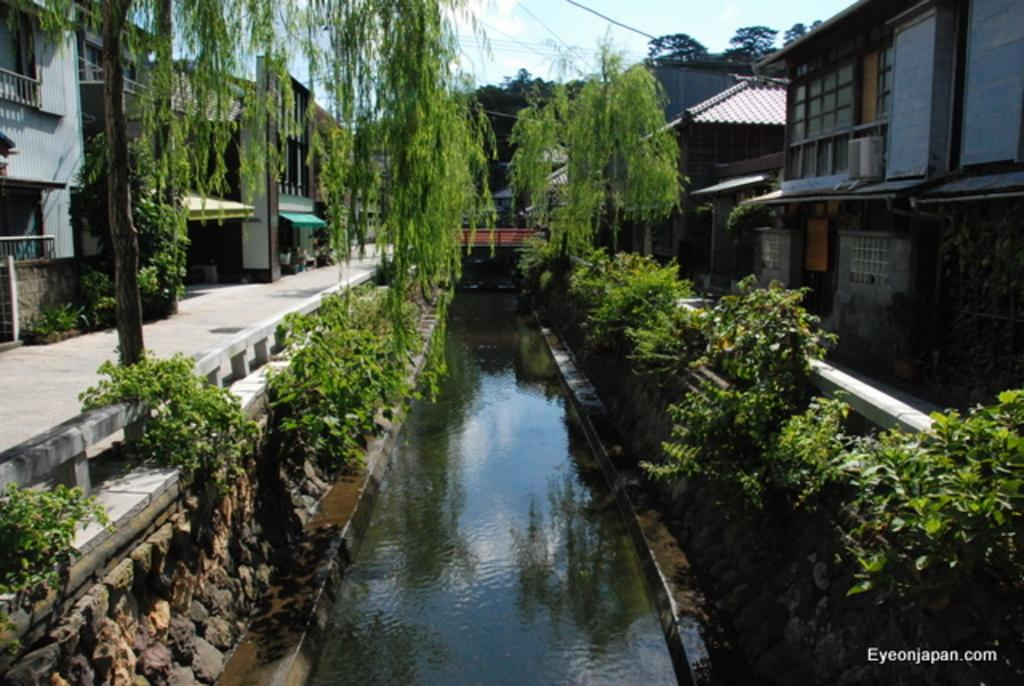What is located in the middle of the image? There is water in the middle of the image. What can be seen beside the water? There are plants beside the water. What type of vegetation is present in the image? There are trees in the image. What type of structures can be seen in the image? There are buildings in the image. Where is the text located in the image? The text is in the bottom right-hand corner of the image. What type of books can be seen in the image? There are no books present in the image. Is there any sleet visible in the image? There is no mention of sleet in the provided facts, and it is not visible in the image. 